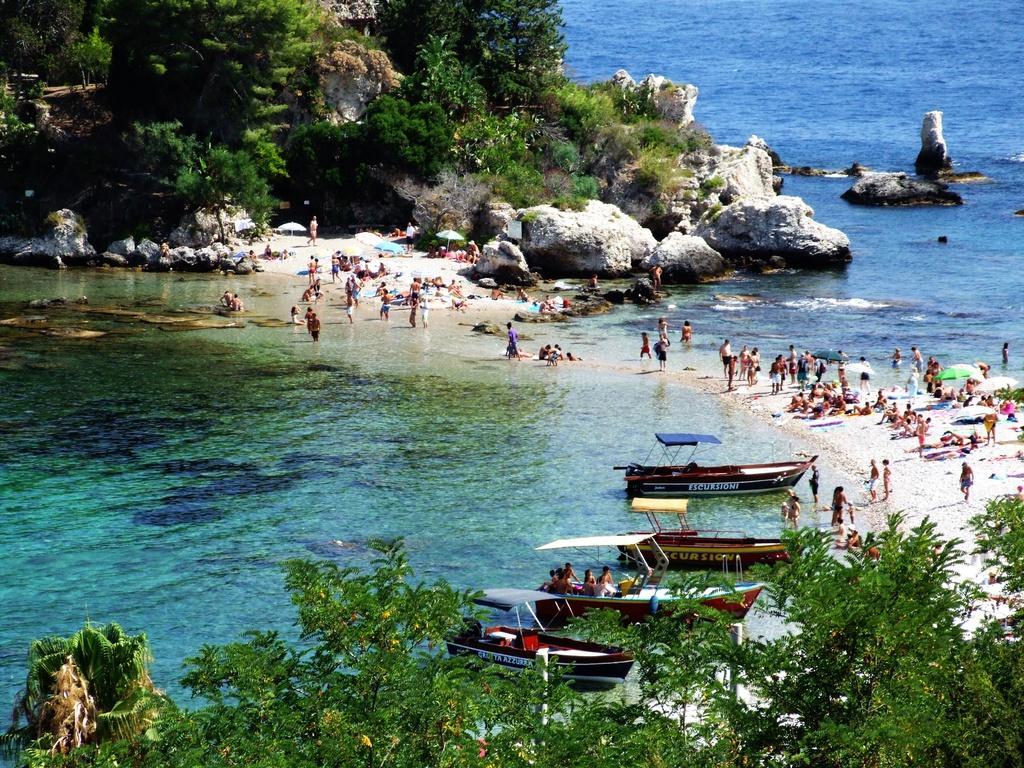Describe this image in one or two sentences. In this picture we can see trees, umbrellas, boats on the water, some people are on a boat and a group of people on the ground and some objects and in the background we can see rocks. 